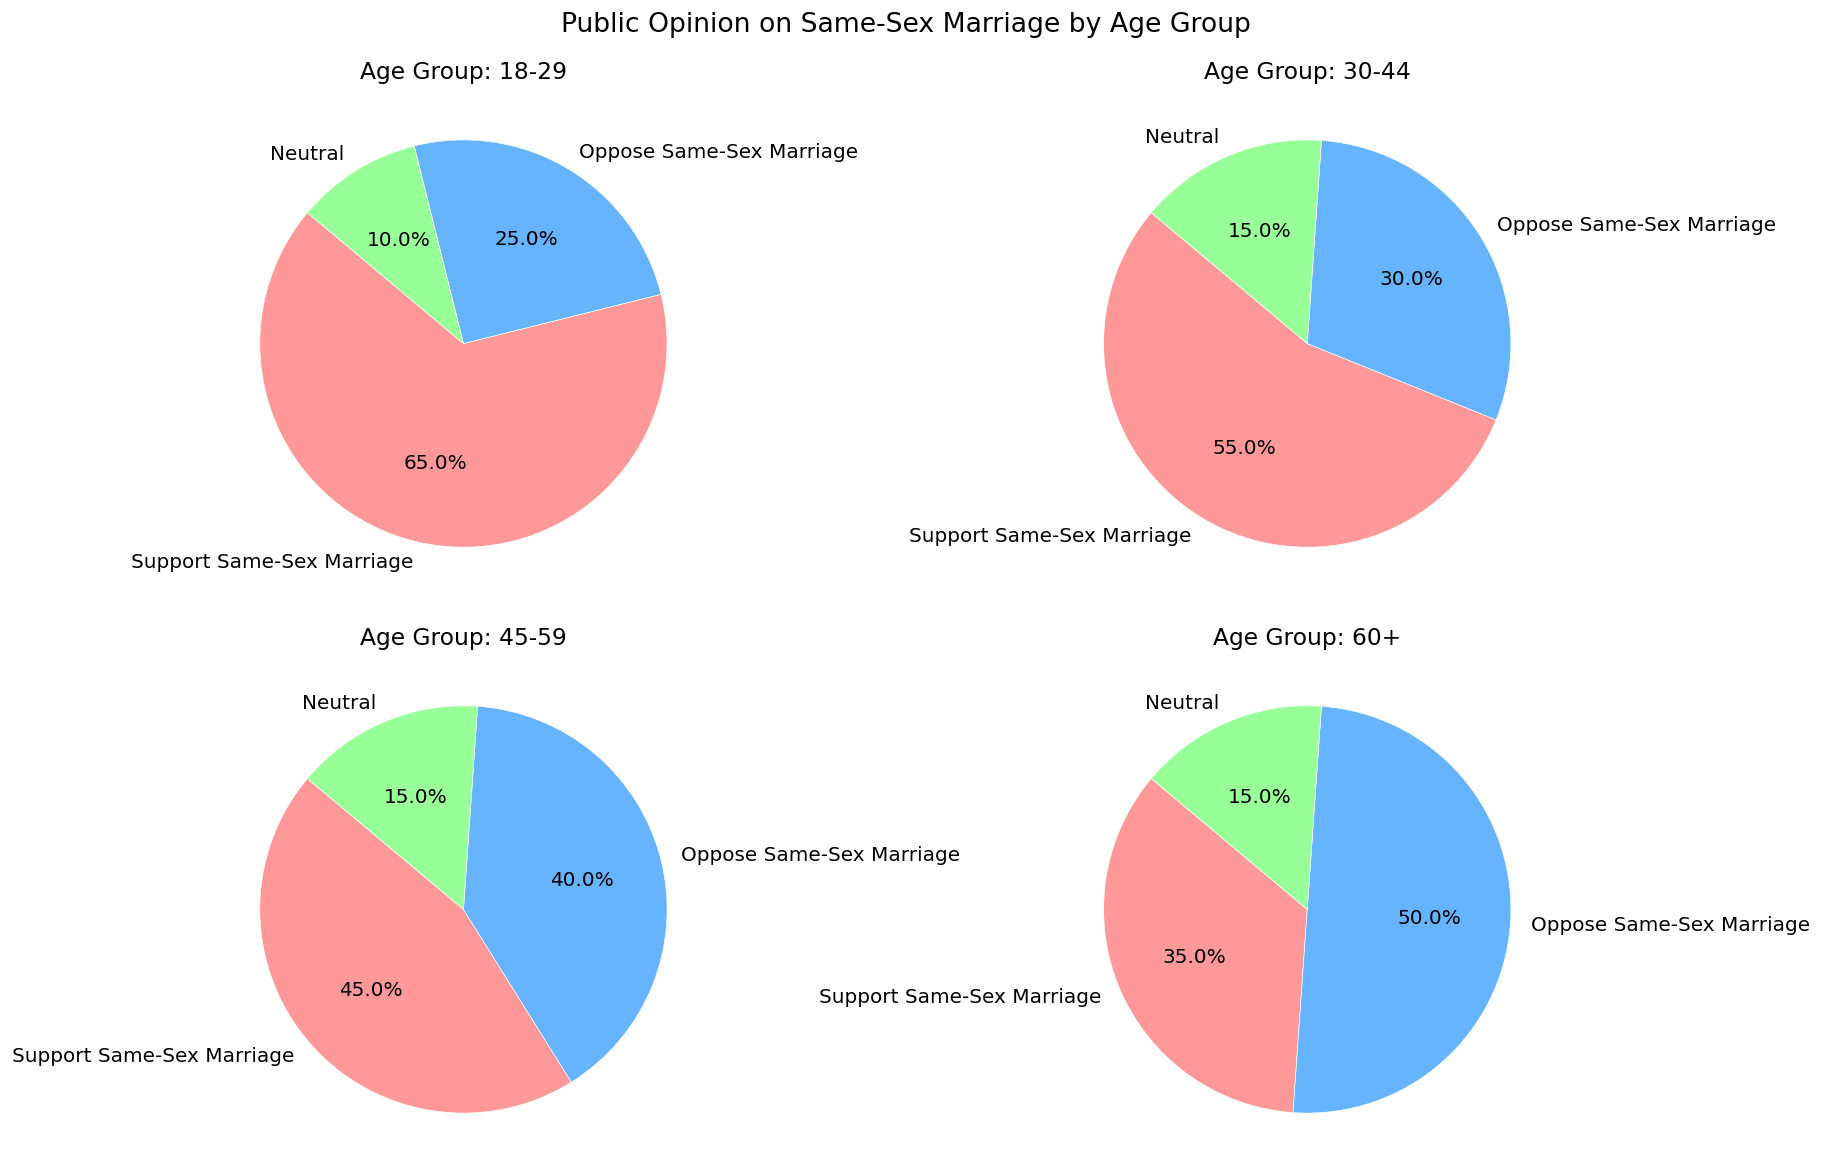What age group has the highest percentage of support for same-sex marriage? To find the age group with the highest percentage of support, look at the segment portion in each pie chart that represents "Support Same-Sex Marriage" and compare them. The largest support percentage is found in the 18-29 age group at 65%.
Answer: 18-29 Which age group is the most opposed to same-sex marriage? To identify the age group with the highest opposition, locate the "Oppose Same-Sex Marriage" segment in each pie chart and compare the percentages. The greatest opposition is in the 60+ age group with 50%.
Answer: 60+ What is the combined percentage of people aged 18-29 and 30-44 who support same-sex marriage? Add the support percentages for both age groups: for 18-29 (65%) and 30-44 (55%). The combined percentage is 65% + 55% = 120%.
Answer: 120% Within the age group 45-59, how does the percentage of those opposing same-sex marriage compare to those who are neutral? Compare the "Oppose" and "Neutral" segments for the 45-59 age group. Opposition is 40%, and neutrality is 15%. The opposition percentage is higher.
Answer: Higher What is the average percentage of people who are neutral across all age groups? Sum the neutral percentages from all age groups: 10% (18-29) + 15% (30-44) + 15% (45-59) + 15% (60+). Divide by the number of age groups (4): (10 + 15 + 15 + 15) / 4 = 13.75%.
Answer: 13.75% In which age group is the gap between support and opposition the smallest? Calculate the difference between support and opposition for each group: (18-29: 65% - 25% = 40%), (30-44: 55% - 30% = 25%), (45-59: 45% - 40% = 5%), (60+: 35% - 50% = -15%). The smallest gap is in the 45-59 age group.
Answer: 45-59 How does the percentage of support in the 60+ age group compare to the 18-29 group? Compare the support segments: 35% for 60+, and 65% for 18-29. The 18-29 group has a higher percentage of support.
Answer: Higher Which age group has the same percentage of neutrality and opposition? Look for age groups where the "Neutral" and "Oppose" segments are identical. None of the age groups meet this criterion.
Answer: None What percentage of the 45-59 age group is either neutral or opposed to same-sex marriage? Add the neutral and opposition percentages: 15% (Neutral) + 40% (Oppose). The total is 55%.
Answer: 55% 